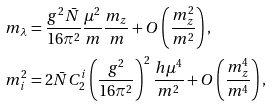<formula> <loc_0><loc_0><loc_500><loc_500>m _ { \lambda } & = \frac { g ^ { 2 } \bar { N } } { 1 6 \pi ^ { 2 } } \frac { \mu ^ { 2 } } { m } \frac { m _ { z } } { m } + O \left ( \frac { m _ { z } ^ { 2 } } { m ^ { 2 } } \right ) , \\ m _ { i } ^ { 2 } & = 2 \bar { N } C _ { 2 } ^ { i } \left ( \frac { g ^ { 2 } } { 1 6 \pi ^ { 2 } } \right ) ^ { 2 } \frac { h \mu ^ { 4 } } { m ^ { 2 } } + O \left ( \frac { m _ { z } ^ { 4 } } { m ^ { 4 } } \right ) ,</formula> 